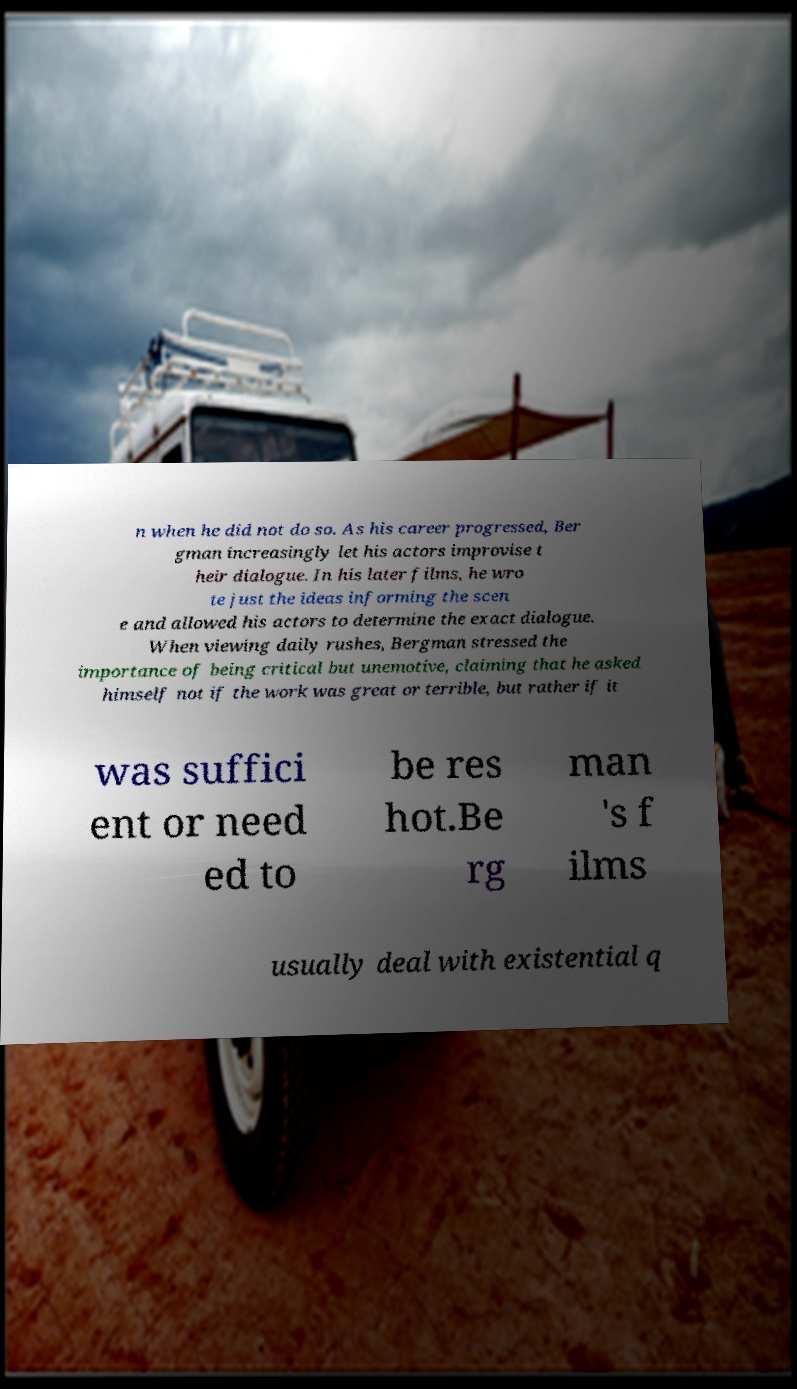For documentation purposes, I need the text within this image transcribed. Could you provide that? n when he did not do so. As his career progressed, Ber gman increasingly let his actors improvise t heir dialogue. In his later films, he wro te just the ideas informing the scen e and allowed his actors to determine the exact dialogue. When viewing daily rushes, Bergman stressed the importance of being critical but unemotive, claiming that he asked himself not if the work was great or terrible, but rather if it was suffici ent or need ed to be res hot.Be rg man 's f ilms usually deal with existential q 